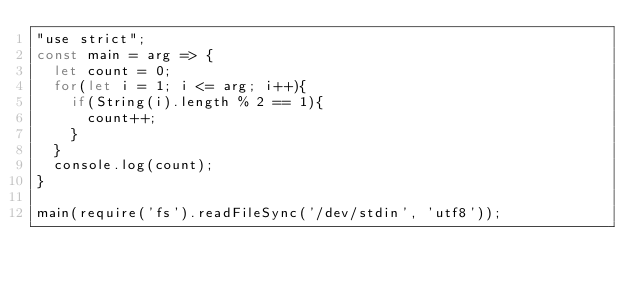<code> <loc_0><loc_0><loc_500><loc_500><_JavaScript_>"use strict";
const main = arg => {
  let count = 0;
  for(let i = 1; i <= arg; i++){
  	if(String(i).length % 2 == 1){
      count++;
    }
  }
  console.log(count);
}

main(require('fs').readFileSync('/dev/stdin', 'utf8'));
</code> 